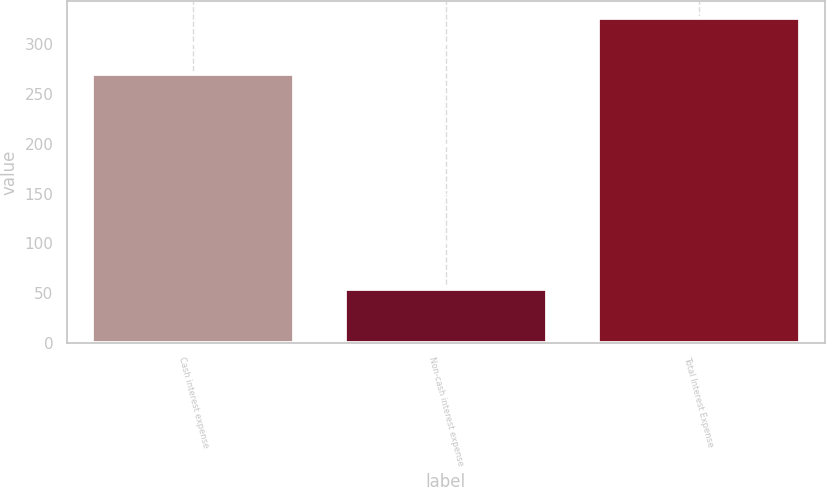<chart> <loc_0><loc_0><loc_500><loc_500><bar_chart><fcel>Cash interest expense<fcel>Non-cash interest expense<fcel>Total Interest Expense<nl><fcel>270<fcel>54<fcel>327<nl></chart> 